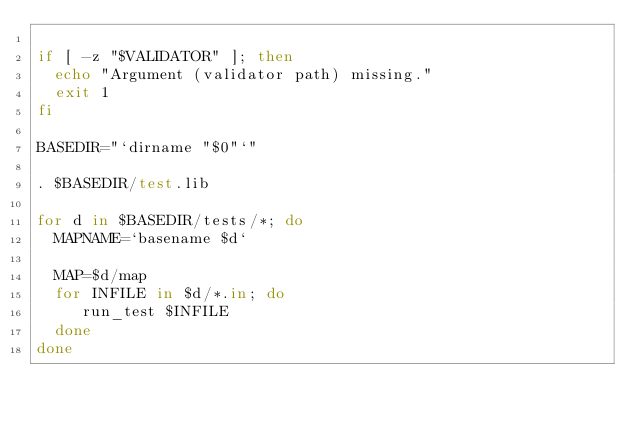Convert code to text. <code><loc_0><loc_0><loc_500><loc_500><_Bash_>
if [ -z "$VALIDATOR" ]; then
  echo "Argument (validator path) missing."
  exit 1
fi

BASEDIR="`dirname "$0"`"

. $BASEDIR/test.lib

for d in $BASEDIR/tests/*; do
  MAPNAME=`basename $d`
  
  MAP=$d/map
  for INFILE in $d/*.in; do
     run_test $INFILE
  done
done
</code> 